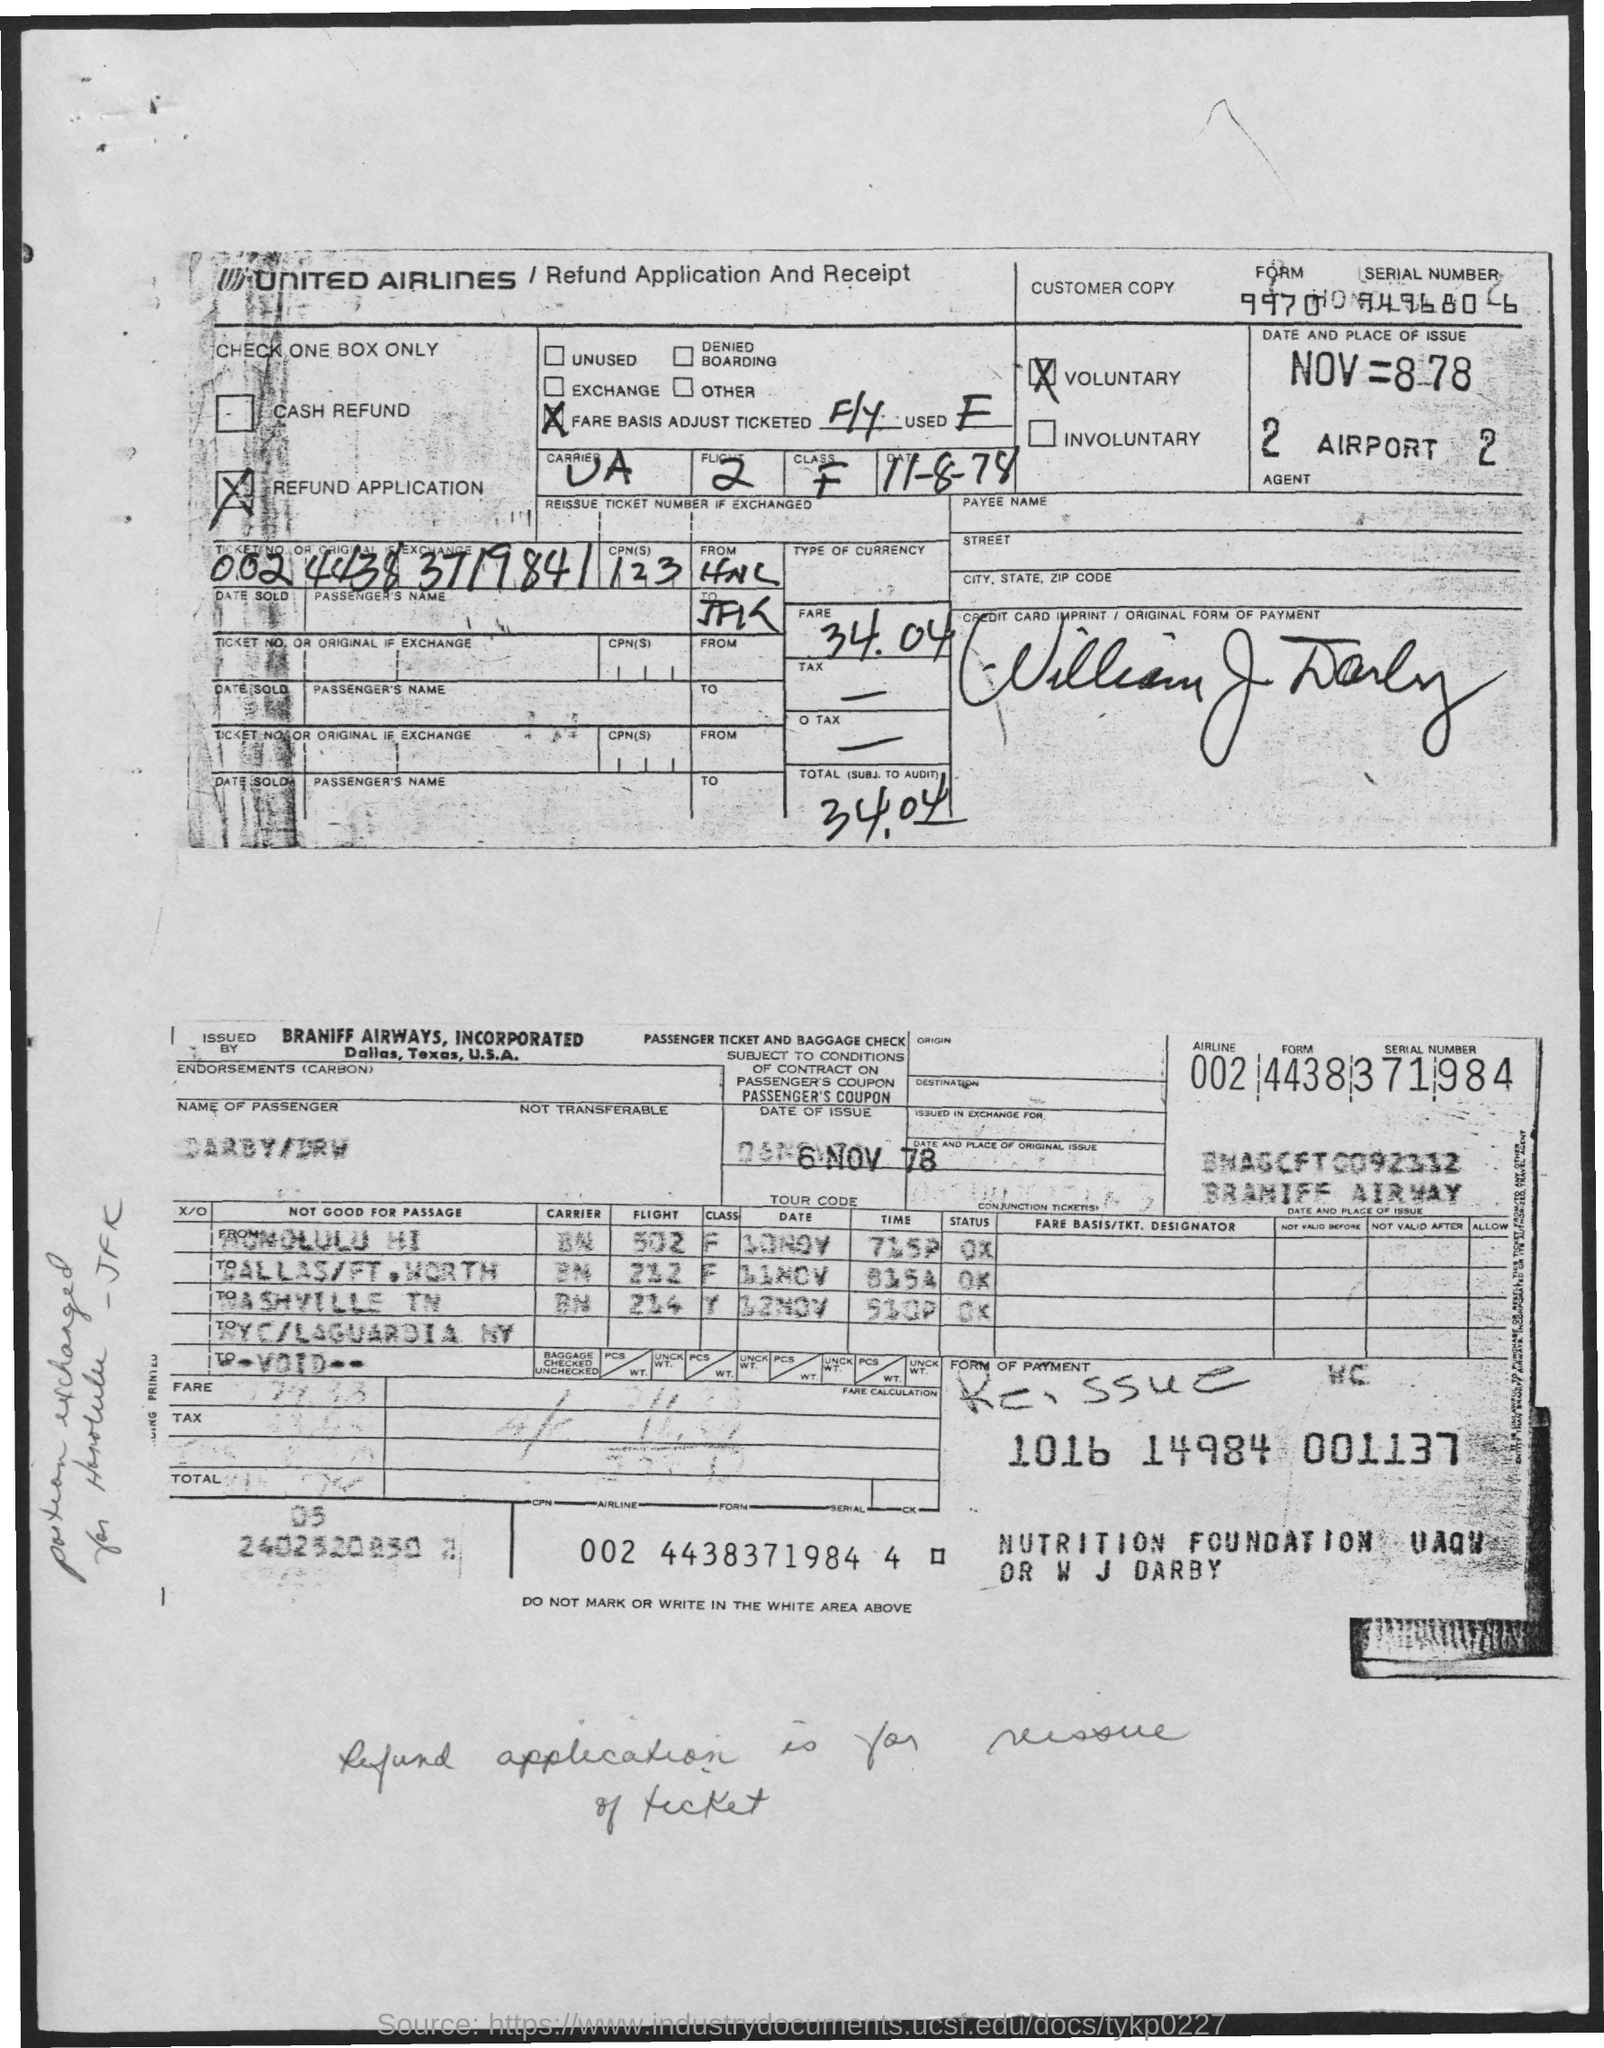Which airlines is mentioned?
Your answer should be compact. UNITED AIRLINES. What type of form is this?
Provide a succinct answer. Refund Application And Receipt. What is the form number on the refund application?
Make the answer very short. 9970. Is it voluntary or involuntary?
Make the answer very short. VOLUNTARY. What is the fare specified?
Your answer should be compact. 34.04. 